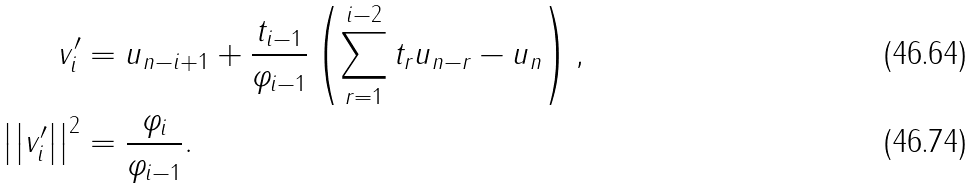<formula> <loc_0><loc_0><loc_500><loc_500>v _ { i } ^ { \prime } & = u _ { n - i + 1 } + \frac { t _ { i - 1 } } { \varphi _ { i - 1 } } \left ( \sum _ { r = 1 } ^ { i - 2 } t _ { r } u _ { n - r } - u _ { n } \right ) , \\ \left | \left | v _ { i } ^ { \prime } \right | \right | ^ { 2 } & = \frac { \varphi _ { i } } { \varphi _ { i - 1 } } .</formula> 